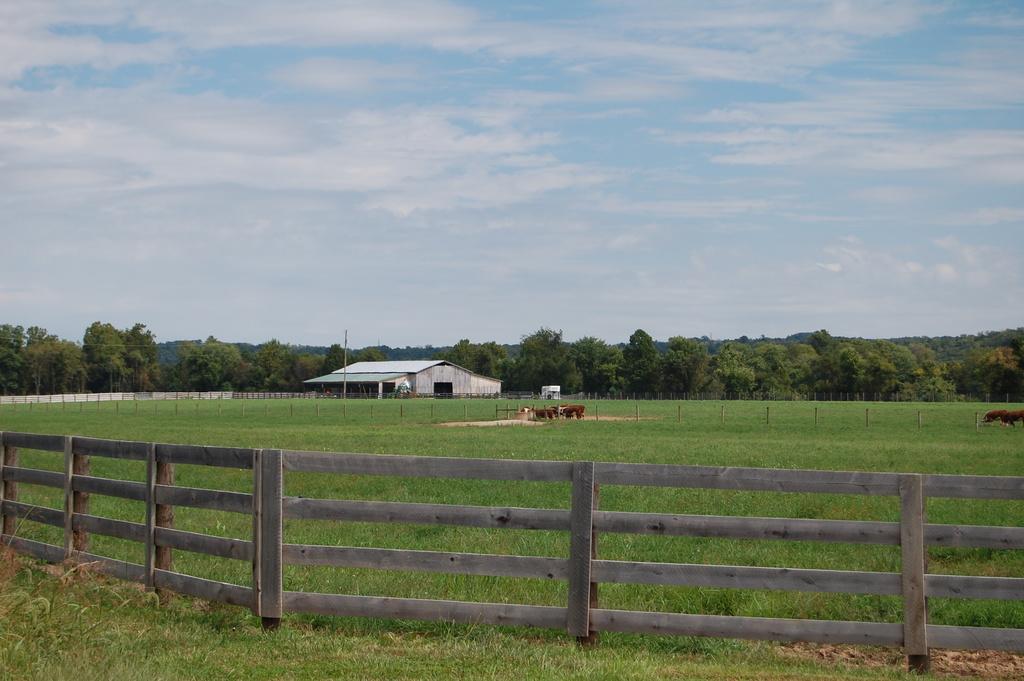Could you give a brief overview of what you see in this image? In the background we can see the clouds in the sky, trees, shelter. In this picture we can see the animals in the field. We can see wooden railings, poles and the green grass. 